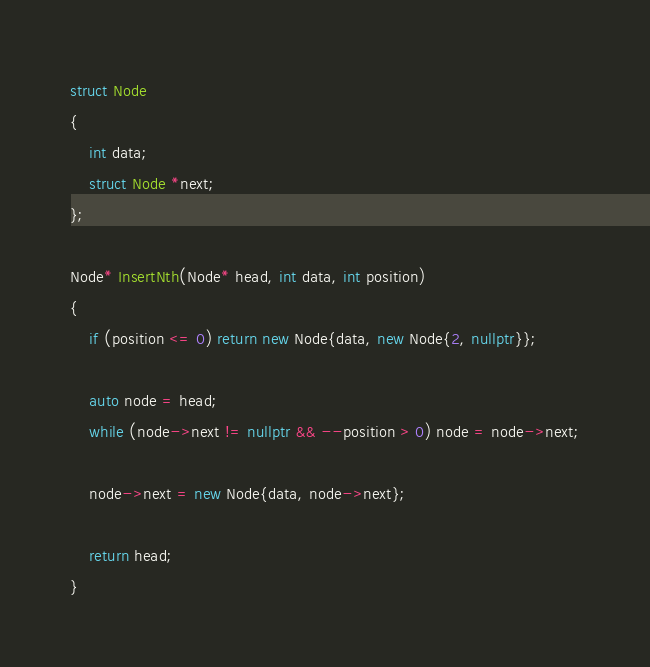<code> <loc_0><loc_0><loc_500><loc_500><_C++_>struct Node
{
    int data;
    struct Node *next;
};

Node* InsertNth(Node* head, int data, int position)
{
    if (position <= 0) return new Node{data, new Node{2, nullptr}};

    auto node = head;
    while (node->next != nullptr && --position > 0) node = node->next;
    
    node->next = new Node{data, node->next};
    
    return head;
}
</code> 